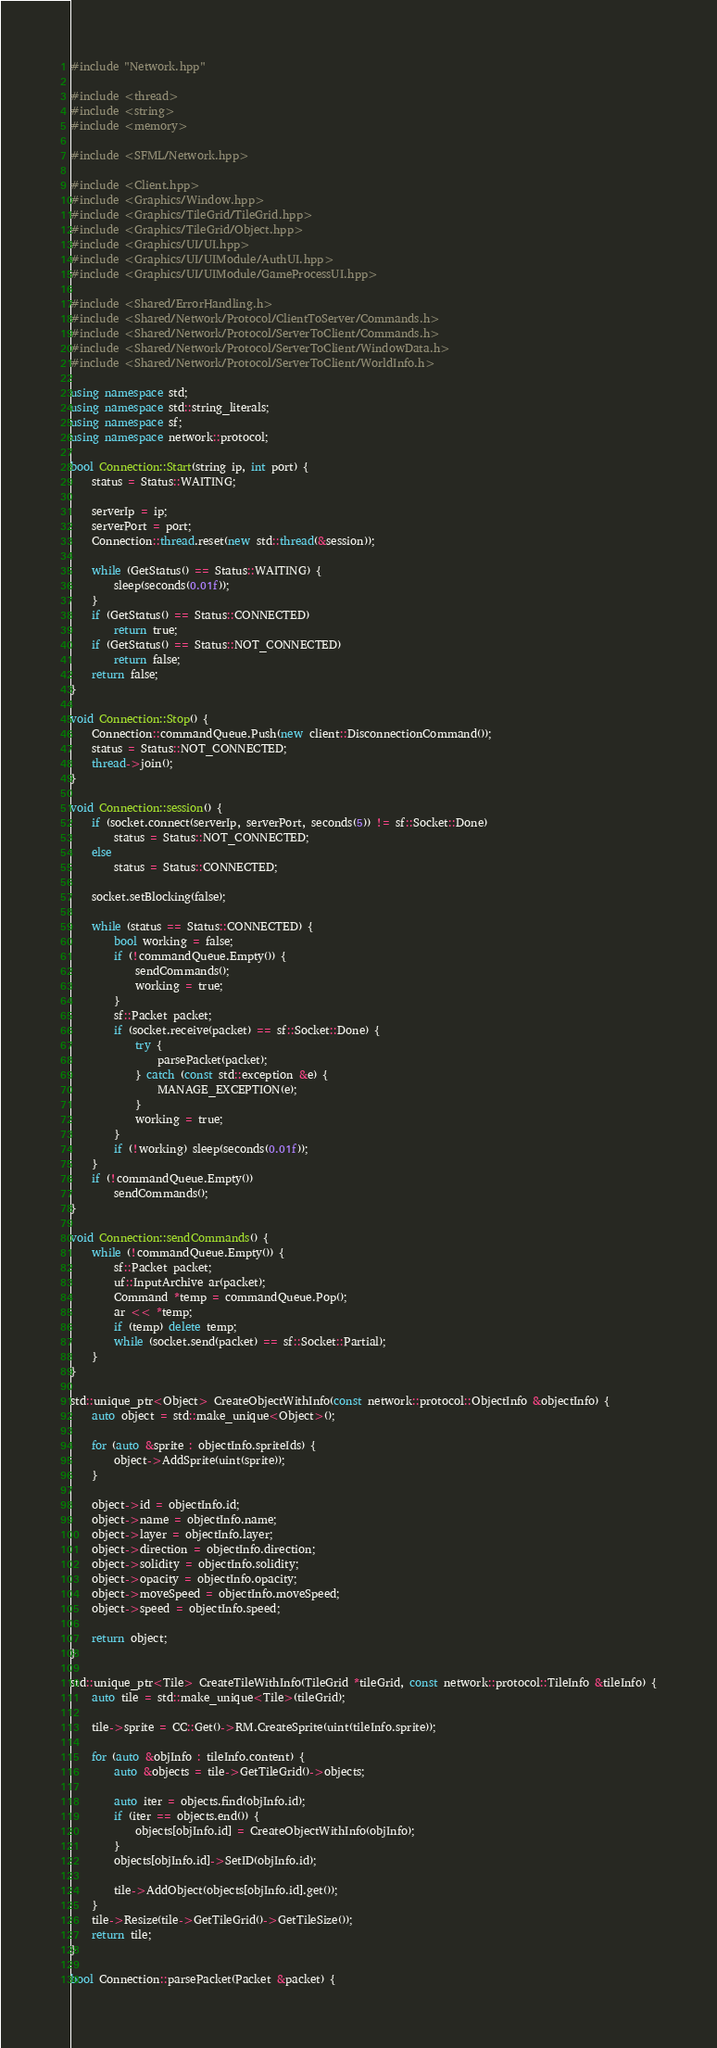Convert code to text. <code><loc_0><loc_0><loc_500><loc_500><_C++_>#include "Network.hpp"

#include <thread>
#include <string>
#include <memory>

#include <SFML/Network.hpp>

#include <Client.hpp>
#include <Graphics/Window.hpp>
#include <Graphics/TileGrid/TileGrid.hpp>
#include <Graphics/TileGrid/Object.hpp>
#include <Graphics/UI/UI.hpp>
#include <Graphics/UI/UIModule/AuthUI.hpp>
#include <Graphics/UI/UIModule/GameProcessUI.hpp>

#include <Shared/ErrorHandling.h>
#include <Shared/Network/Protocol/ClientToServer/Commands.h>
#include <Shared/Network/Protocol/ServerToClient/Commands.h>
#include <Shared/Network/Protocol/ServerToClient/WindowData.h>
#include <Shared/Network/Protocol/ServerToClient/WorldInfo.h>

using namespace std;
using namespace std::string_literals;
using namespace sf;
using namespace network::protocol;

bool Connection::Start(string ip, int port) {
    status = Status::WAITING;

    serverIp = ip;
    serverPort = port;
    Connection::thread.reset(new std::thread(&session));

    while (GetStatus() == Status::WAITING) {
        sleep(seconds(0.01f));
    }
    if (GetStatus() == Status::CONNECTED)
        return true;
    if (GetStatus() == Status::NOT_CONNECTED)
        return false;
    return false;
}

void Connection::Stop() {
    Connection::commandQueue.Push(new client::DisconnectionCommand());
    status = Status::NOT_CONNECTED;
    thread->join();
}

void Connection::session() {
	if (socket.connect(serverIp, serverPort, seconds(5)) != sf::Socket::Done)
		status = Status::NOT_CONNECTED;
	else
		status = Status::CONNECTED;

	socket.setBlocking(false);

	while (status == Status::CONNECTED) {
		bool working = false;
		if (!commandQueue.Empty()) {
			sendCommands();
			working = true;
		}
		sf::Packet packet;
		if (socket.receive(packet) == sf::Socket::Done) {
			try {
				parsePacket(packet);
			} catch (const std::exception &e) {
				MANAGE_EXCEPTION(e);
			}
			working = true;
		}
		if (!working) sleep(seconds(0.01f));
	}
	if (!commandQueue.Empty())
		sendCommands();
}

void Connection::sendCommands() {
	while (!commandQueue.Empty()) {
		sf::Packet packet;
		uf::InputArchive ar(packet);
		Command *temp = commandQueue.Pop();
		ar << *temp;
		if (temp) delete temp;
		while (socket.send(packet) == sf::Socket::Partial);
	}
}

std::unique_ptr<Object> CreateObjectWithInfo(const network::protocol::ObjectInfo &objectInfo) {
	auto object = std::make_unique<Object>();

	for (auto &sprite : objectInfo.spriteIds) {
		object->AddSprite(uint(sprite));
	}

	object->id = objectInfo.id;
	object->name = objectInfo.name;
	object->layer = objectInfo.layer;
	object->direction = objectInfo.direction;
	object->solidity = objectInfo.solidity;
	object->opacity = objectInfo.opacity;
	object->moveSpeed = objectInfo.moveSpeed;
	object->speed = objectInfo.speed;

	return object;
}

std::unique_ptr<Tile> CreateTileWithInfo(TileGrid *tileGrid, const network::protocol::TileInfo &tileInfo) {
	auto tile = std::make_unique<Tile>(tileGrid);

	tile->sprite = CC::Get()->RM.CreateSprite(uint(tileInfo.sprite));

	for (auto &objInfo : tileInfo.content) {
		auto &objects = tile->GetTileGrid()->objects;

		auto iter = objects.find(objInfo.id);
		if (iter == objects.end()) {
			objects[objInfo.id] = CreateObjectWithInfo(objInfo);
		}
		objects[objInfo.id]->SetID(objInfo.id);

		tile->AddObject(objects[objInfo.id].get());
	}
	tile->Resize(tile->GetTileGrid()->GetTileSize());
	return tile;
}

bool Connection::parsePacket(Packet &packet) {</code> 